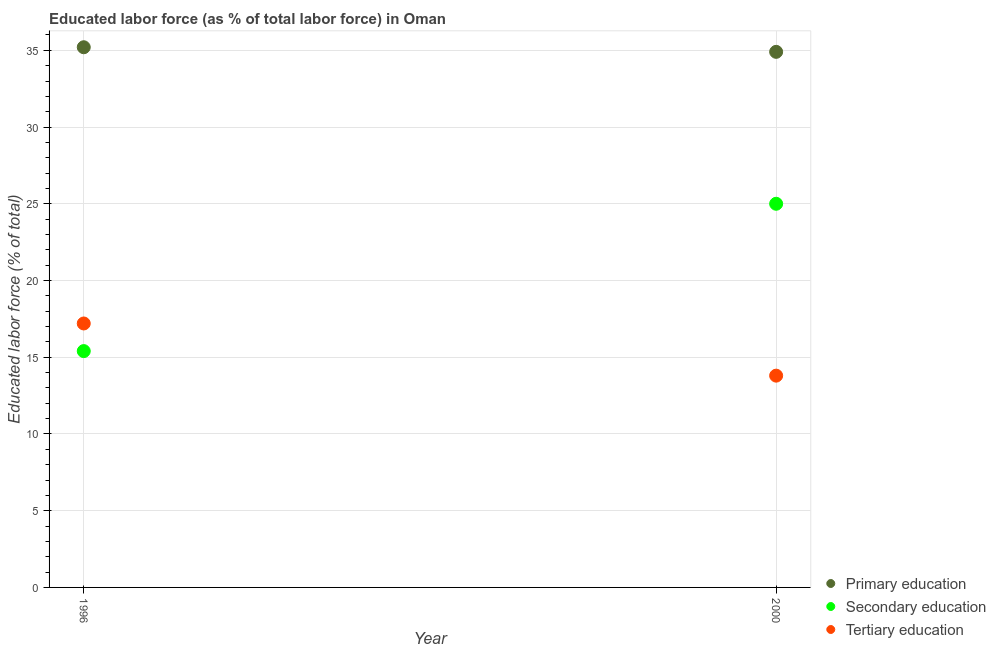Is the number of dotlines equal to the number of legend labels?
Keep it short and to the point. Yes. What is the percentage of labor force who received primary education in 2000?
Your answer should be compact. 34.9. Across all years, what is the maximum percentage of labor force who received primary education?
Make the answer very short. 35.2. Across all years, what is the minimum percentage of labor force who received secondary education?
Give a very brief answer. 15.4. In which year was the percentage of labor force who received primary education minimum?
Provide a short and direct response. 2000. What is the total percentage of labor force who received primary education in the graph?
Provide a short and direct response. 70.1. What is the difference between the percentage of labor force who received tertiary education in 1996 and that in 2000?
Keep it short and to the point. 3.4. What is the difference between the percentage of labor force who received tertiary education in 1996 and the percentage of labor force who received primary education in 2000?
Your answer should be compact. -17.7. What is the average percentage of labor force who received tertiary education per year?
Keep it short and to the point. 15.5. In the year 2000, what is the difference between the percentage of labor force who received primary education and percentage of labor force who received secondary education?
Provide a succinct answer. 9.9. In how many years, is the percentage of labor force who received primary education greater than 8 %?
Keep it short and to the point. 2. What is the ratio of the percentage of labor force who received tertiary education in 1996 to that in 2000?
Make the answer very short. 1.25. In how many years, is the percentage of labor force who received tertiary education greater than the average percentage of labor force who received tertiary education taken over all years?
Your answer should be very brief. 1. Is the percentage of labor force who received secondary education strictly less than the percentage of labor force who received primary education over the years?
Your answer should be very brief. Yes. What is the difference between two consecutive major ticks on the Y-axis?
Provide a short and direct response. 5. Does the graph contain grids?
Ensure brevity in your answer.  Yes. Where does the legend appear in the graph?
Your answer should be very brief. Bottom right. What is the title of the graph?
Offer a very short reply. Educated labor force (as % of total labor force) in Oman. Does "Infant(male)" appear as one of the legend labels in the graph?
Keep it short and to the point. No. What is the label or title of the Y-axis?
Your answer should be very brief. Educated labor force (% of total). What is the Educated labor force (% of total) in Primary education in 1996?
Give a very brief answer. 35.2. What is the Educated labor force (% of total) in Secondary education in 1996?
Your answer should be compact. 15.4. What is the Educated labor force (% of total) of Tertiary education in 1996?
Make the answer very short. 17.2. What is the Educated labor force (% of total) of Primary education in 2000?
Your answer should be compact. 34.9. What is the Educated labor force (% of total) in Secondary education in 2000?
Ensure brevity in your answer.  25. What is the Educated labor force (% of total) of Tertiary education in 2000?
Make the answer very short. 13.8. Across all years, what is the maximum Educated labor force (% of total) of Primary education?
Your answer should be compact. 35.2. Across all years, what is the maximum Educated labor force (% of total) of Tertiary education?
Offer a terse response. 17.2. Across all years, what is the minimum Educated labor force (% of total) of Primary education?
Your answer should be very brief. 34.9. Across all years, what is the minimum Educated labor force (% of total) of Secondary education?
Provide a short and direct response. 15.4. Across all years, what is the minimum Educated labor force (% of total) of Tertiary education?
Make the answer very short. 13.8. What is the total Educated labor force (% of total) in Primary education in the graph?
Your answer should be very brief. 70.1. What is the total Educated labor force (% of total) of Secondary education in the graph?
Your answer should be very brief. 40.4. What is the total Educated labor force (% of total) of Tertiary education in the graph?
Give a very brief answer. 31. What is the difference between the Educated labor force (% of total) in Secondary education in 1996 and that in 2000?
Offer a very short reply. -9.6. What is the difference between the Educated labor force (% of total) of Primary education in 1996 and the Educated labor force (% of total) of Secondary education in 2000?
Your answer should be very brief. 10.2. What is the difference between the Educated labor force (% of total) of Primary education in 1996 and the Educated labor force (% of total) of Tertiary education in 2000?
Offer a terse response. 21.4. What is the difference between the Educated labor force (% of total) of Secondary education in 1996 and the Educated labor force (% of total) of Tertiary education in 2000?
Make the answer very short. 1.6. What is the average Educated labor force (% of total) of Primary education per year?
Your response must be concise. 35.05. What is the average Educated labor force (% of total) in Secondary education per year?
Make the answer very short. 20.2. In the year 1996, what is the difference between the Educated labor force (% of total) in Primary education and Educated labor force (% of total) in Secondary education?
Provide a succinct answer. 19.8. In the year 1996, what is the difference between the Educated labor force (% of total) in Secondary education and Educated labor force (% of total) in Tertiary education?
Keep it short and to the point. -1.8. In the year 2000, what is the difference between the Educated labor force (% of total) of Primary education and Educated labor force (% of total) of Secondary education?
Provide a succinct answer. 9.9. In the year 2000, what is the difference between the Educated labor force (% of total) in Primary education and Educated labor force (% of total) in Tertiary education?
Provide a short and direct response. 21.1. In the year 2000, what is the difference between the Educated labor force (% of total) of Secondary education and Educated labor force (% of total) of Tertiary education?
Offer a terse response. 11.2. What is the ratio of the Educated labor force (% of total) of Primary education in 1996 to that in 2000?
Give a very brief answer. 1.01. What is the ratio of the Educated labor force (% of total) in Secondary education in 1996 to that in 2000?
Ensure brevity in your answer.  0.62. What is the ratio of the Educated labor force (% of total) in Tertiary education in 1996 to that in 2000?
Ensure brevity in your answer.  1.25. What is the difference between the highest and the second highest Educated labor force (% of total) of Secondary education?
Make the answer very short. 9.6. What is the difference between the highest and the second highest Educated labor force (% of total) of Tertiary education?
Provide a short and direct response. 3.4. What is the difference between the highest and the lowest Educated labor force (% of total) of Primary education?
Provide a short and direct response. 0.3. 